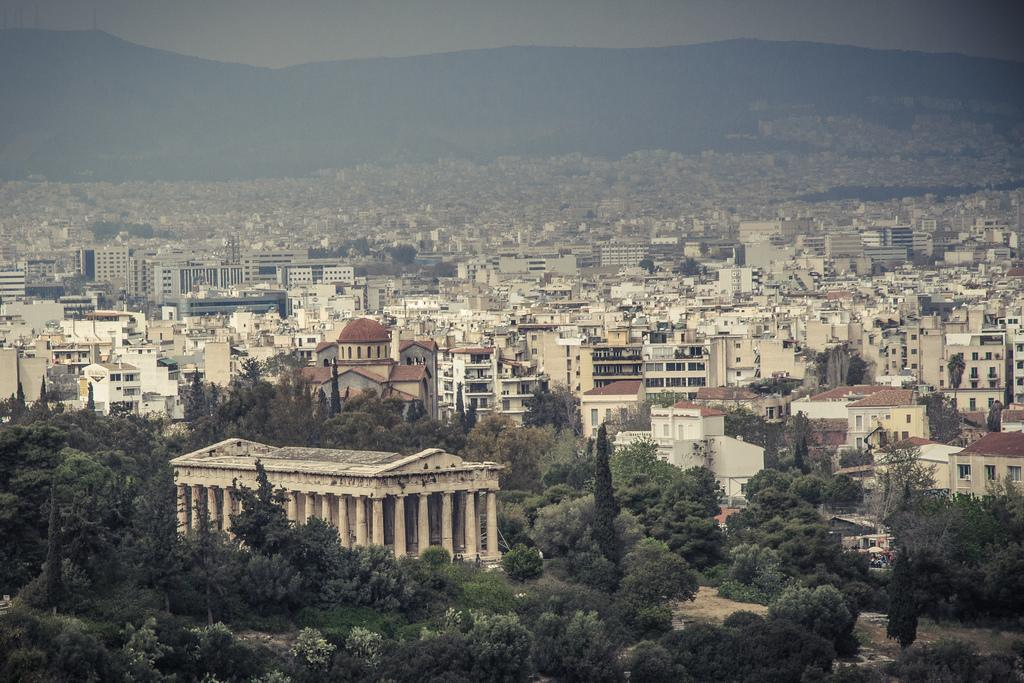What is the main subject in the center of the image? There are many buildings in the center of the image. What type of vegetation can be seen at the bottom of the image? There are trees at the bottom of the image. What geographical features are visible in the background of the image? There are hills in the background of the image. What part of the natural environment is visible in the background of the image? The sky is visible in the background of the image. What organization is responsible for the good-bye message on the buildings in the image? There is no good-bye message or organization mentioned in the image; it only features buildings, trees, hills, and the sky. 